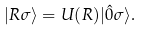<formula> <loc_0><loc_0><loc_500><loc_500>| R \sigma \rangle = U ( R ) | \hat { 0 } \sigma \rangle .</formula> 